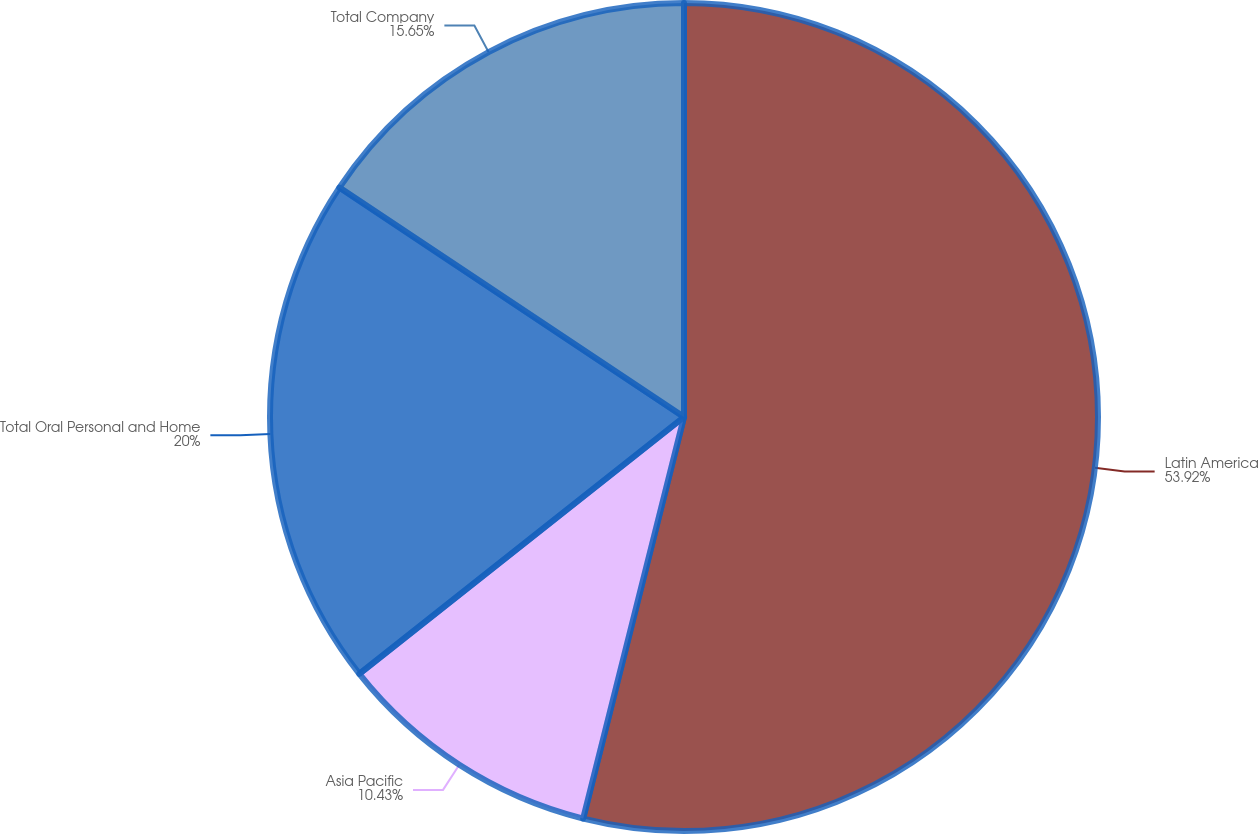Convert chart. <chart><loc_0><loc_0><loc_500><loc_500><pie_chart><fcel>Latin America<fcel>Asia Pacific<fcel>Total Oral Personal and Home<fcel>Total Company<nl><fcel>53.91%<fcel>10.43%<fcel>20.0%<fcel>15.65%<nl></chart> 